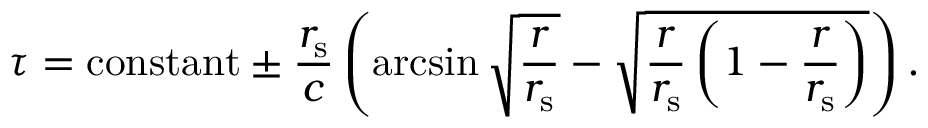<formula> <loc_0><loc_0><loc_500><loc_500>\tau = { c o n s t a n t } \pm { \frac { r _ { s } } { c } } \left ( \arcsin { \sqrt { \frac { r } { r _ { s } } } } - { \sqrt { { \frac { r } { r _ { s } } } \left ( 1 - { \frac { r } { r _ { s } } } \right ) } } \right ) .</formula> 